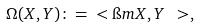Convert formula to latex. <formula><loc_0><loc_0><loc_500><loc_500>\Omega ( X , Y ) \colon = \ < \i m X , Y \ > ,</formula> 